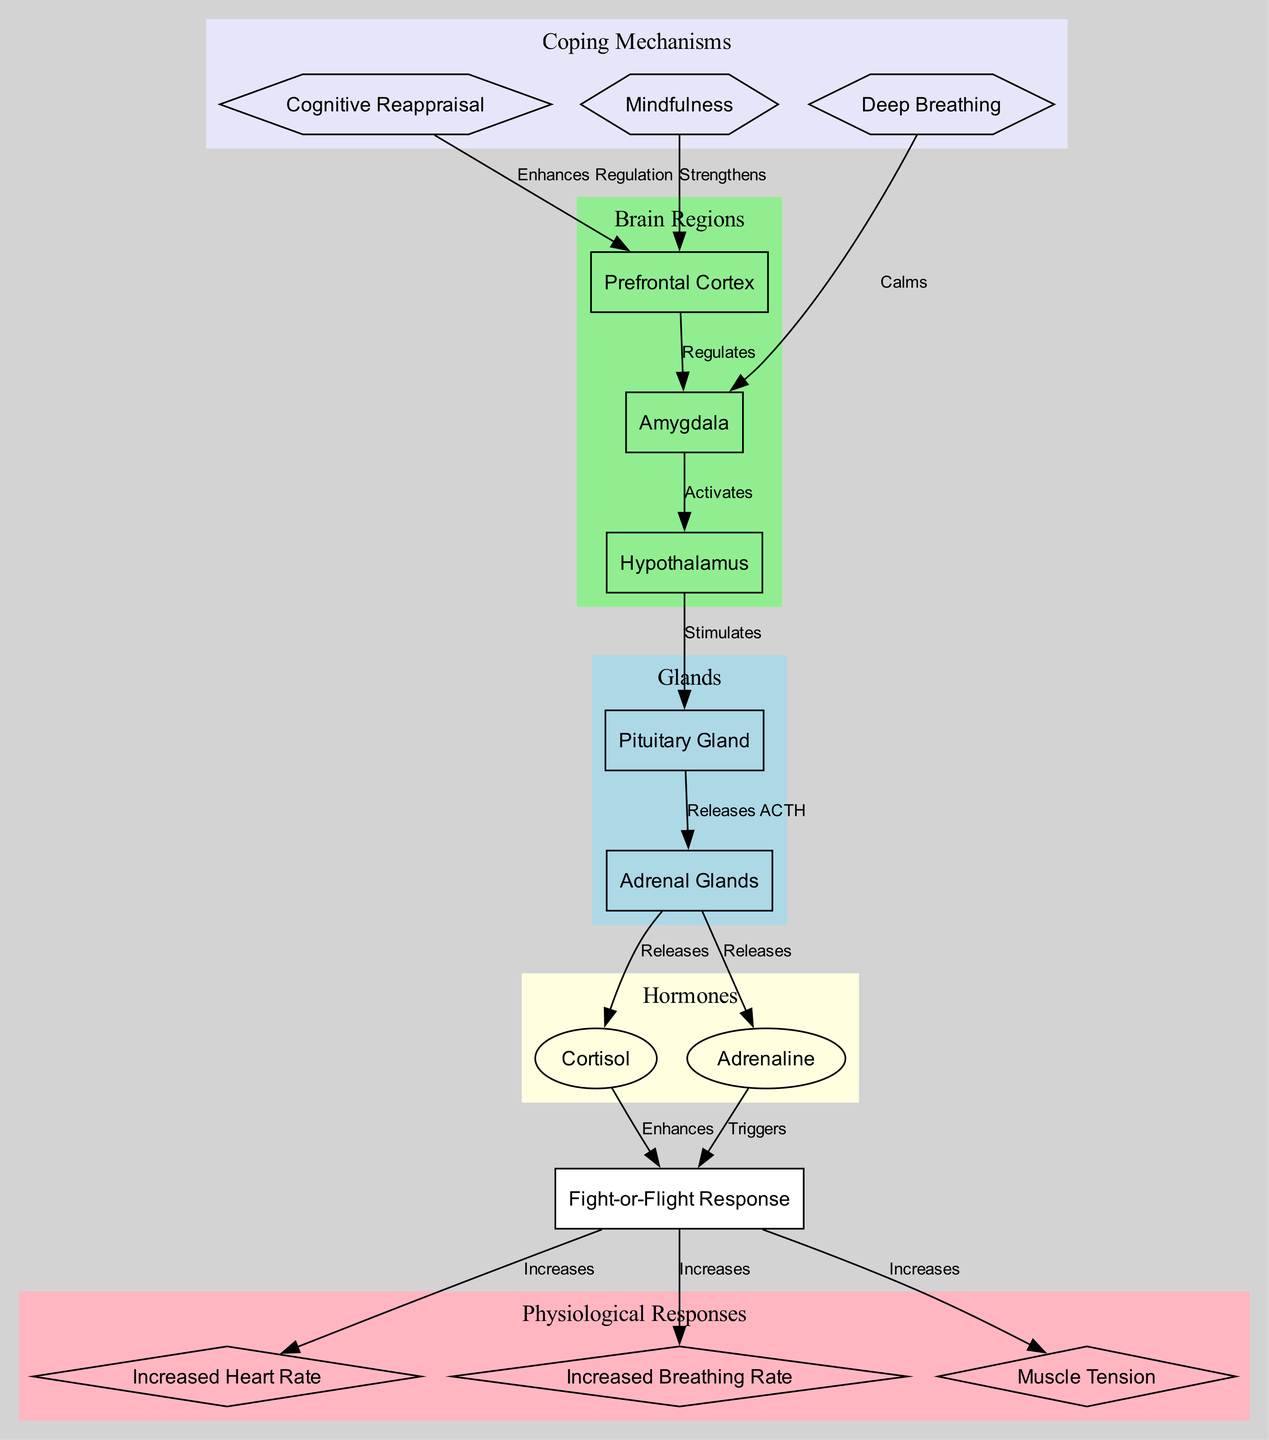What brain region activates the hypothalamus in response to stage fright? The diagram shows that the amygdala activates the hypothalamus, indicating its role in the emotional response to fear or stress, such as stage fright.
Answer: Amygdala What do the adrenal glands release in response to stimulation from the pituitary gland? The diagram indicates that the pituitary gland releases ACTH, which stimulates the adrenal glands to release cortisol and adrenaline.
Answer: Cortisol and Adrenaline What physiological response increases due to the fight-or-flight response? The diagram highlights three physiological responses that increase due to the fight-or-flight response: heart rate, breathing rate, and muscle tension.
Answer: Increased Heart Rate, Increased Breathing Rate, Muscle Tension Which coping mechanism enhances the regulation of the amygdala by the prefrontal cortex? According to the diagram, cognitive reappraisal enhances the prefrontal cortex's regulation of the amygdala, suggesting it helps manage emotional responses.
Answer: Cognitive Reappraisal How many nodes are classified under physiological responses in the diagram? There are three nodes listed under physiological responses: heart rate, breathing rate, and muscle tension. Therefore, by counting those, we find that there are three nodes in that category.
Answer: 3 Which neurotransmitter enhances the fight-or-flight response? The diagram shows that cortisol, released by the adrenal glands, enhances the fight-or-flight response, indicating its role in stress reactions.
Answer: Cortisol What effect does deep breathing have on the amygdala? The diagram states that deep breathing calms the amygdala, which is integral in the stress response. This implies that it helps reduce anxiety associated with stage fright.
Answer: Calms Which brain region is responsible for regulating the amygdala's response to stress? The diagram indicates that the prefrontal cortex regulates the amygdala, meaning it plays a critical role in moderating emotional reactions and decisions pertaining to fear.
Answer: Prefrontal Cortex 